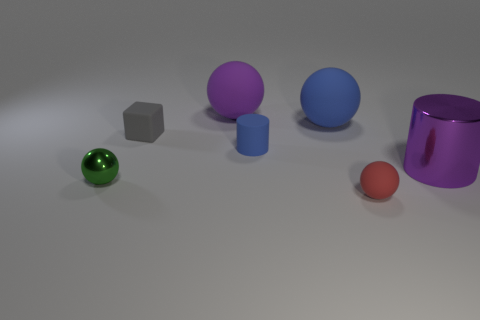Add 2 metallic things. How many objects exist? 9 Subtract all cylinders. How many objects are left? 5 Add 2 large gray metal cylinders. How many large gray metal cylinders exist? 2 Subtract 0 gray balls. How many objects are left? 7 Subtract all rubber cylinders. Subtract all large purple objects. How many objects are left? 4 Add 4 tiny blue cylinders. How many tiny blue cylinders are left? 5 